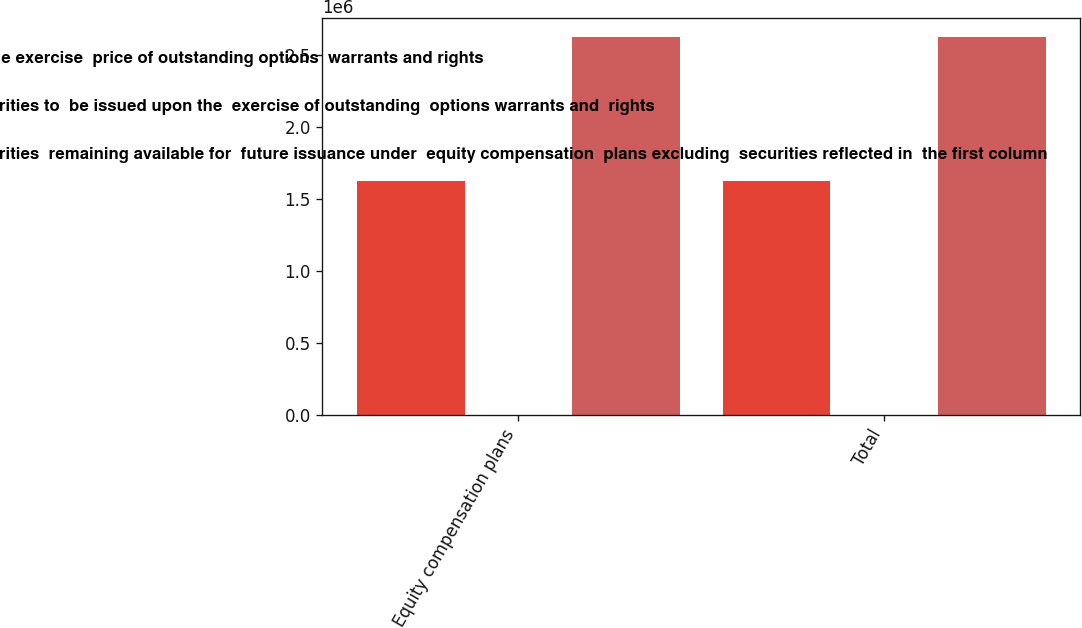Convert chart. <chart><loc_0><loc_0><loc_500><loc_500><stacked_bar_chart><ecel><fcel>Equity compensation plans<fcel>Total<nl><fcel>Weightedaverage exercise  price of outstanding options  warrants and rights<fcel>1.6231e+06<fcel>1.6231e+06<nl><fcel>Number of securities to  be issued upon the  exercise of outstanding  options warrants and  rights<fcel>22.17<fcel>22.17<nl><fcel>Number of securities  remaining available for  future issuance under  equity compensation  plans excluding  securities reflected in  the first column<fcel>2.62202e+06<fcel>2.62202e+06<nl></chart> 